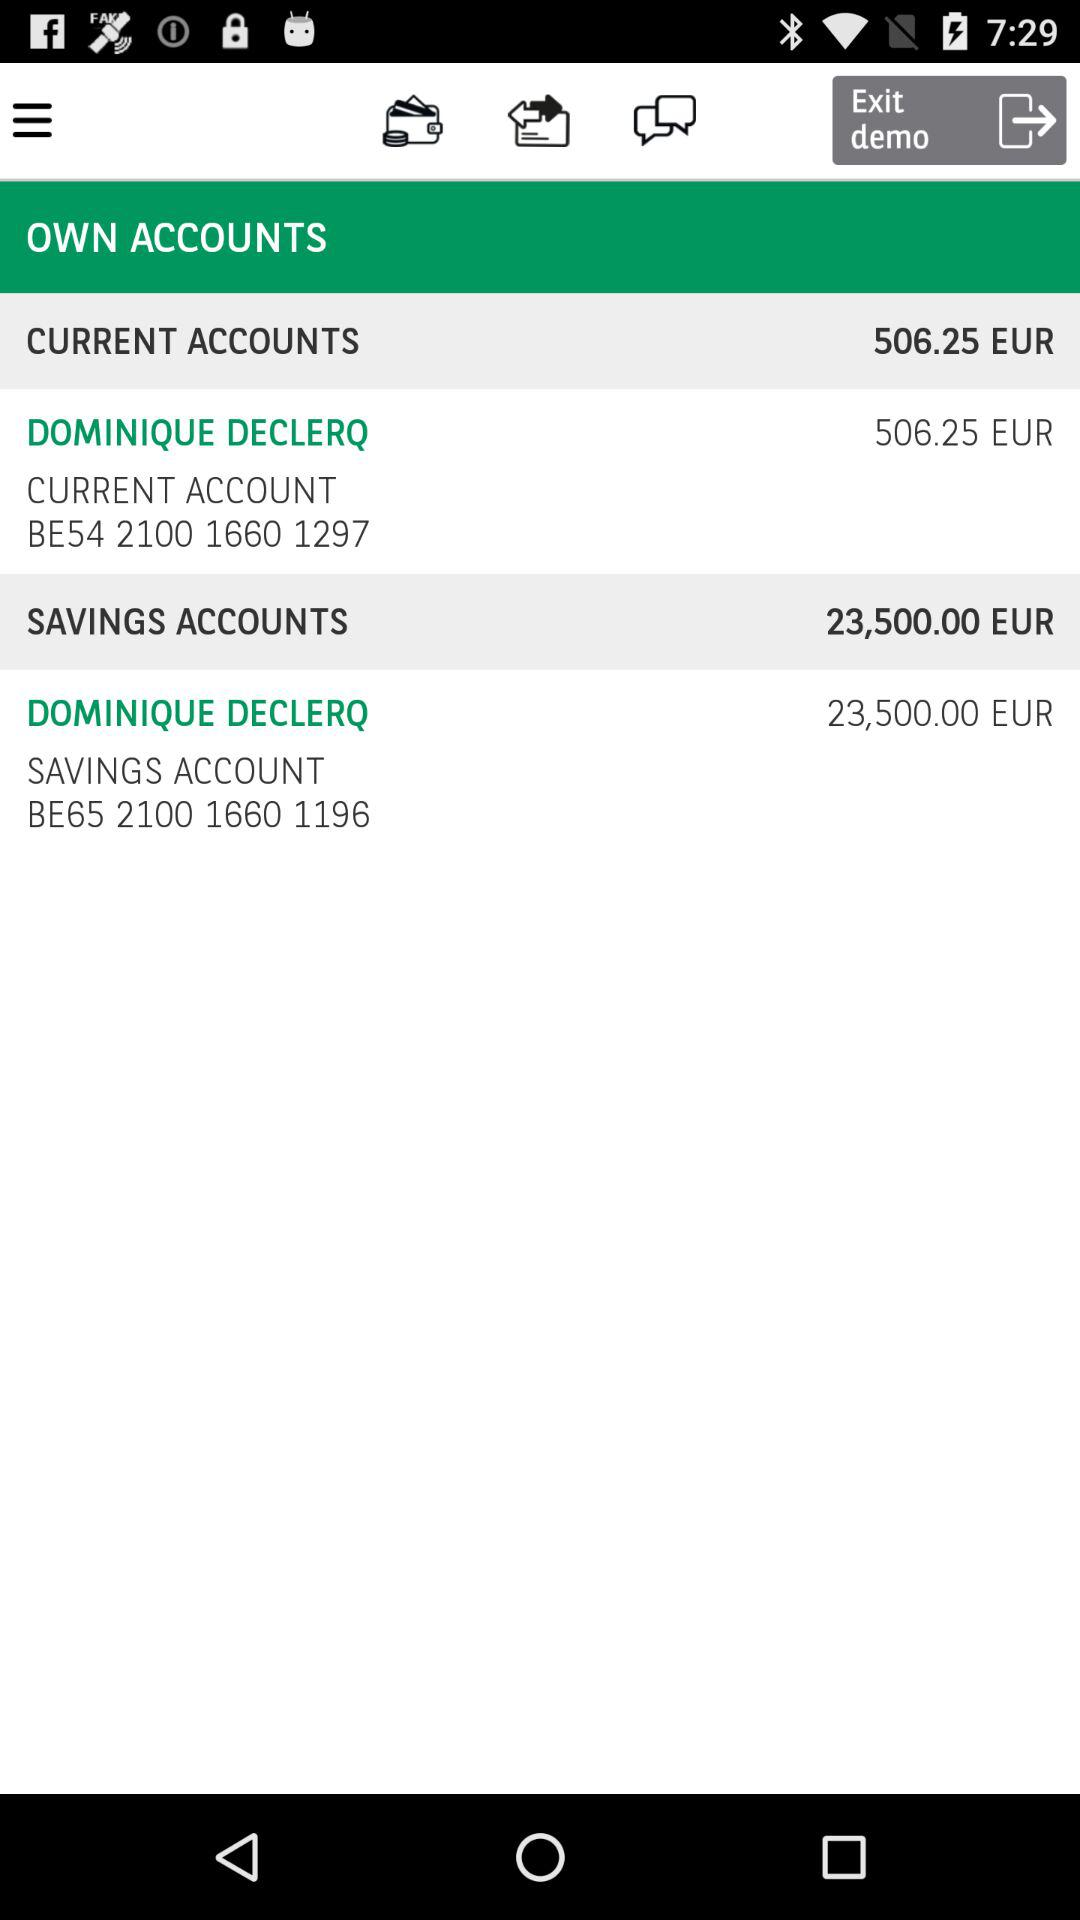What is the given savings account number? The given savings account number is BE65 2100 1660 1196. 